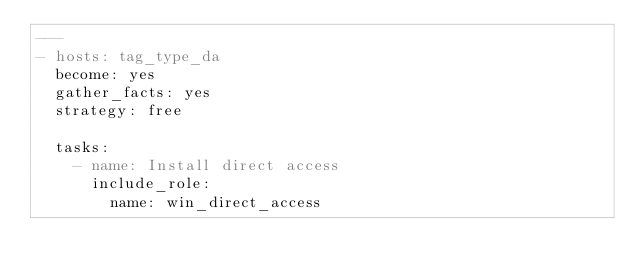Convert code to text. <code><loc_0><loc_0><loc_500><loc_500><_YAML_>---
- hosts: tag_type_da
  become: yes
  gather_facts: yes
  strategy: free

  tasks:
    - name: Install direct access
      include_role:
        name: win_direct_access
</code> 